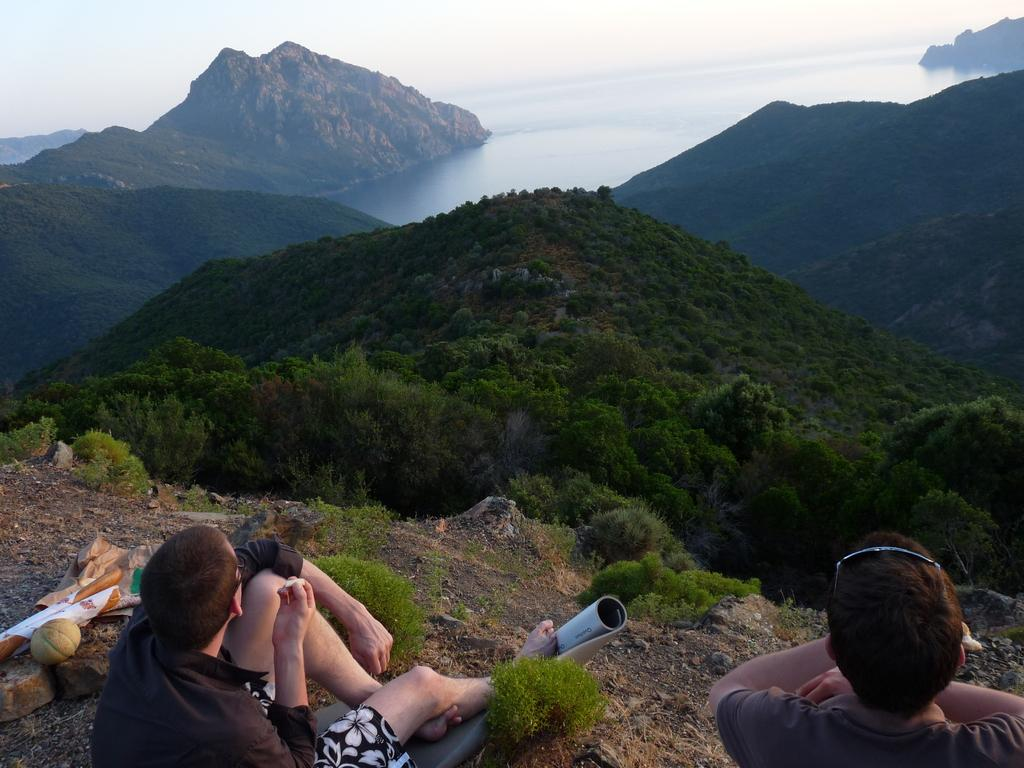Who or what can be seen in the image? There are people in the image. What type of natural environment is visible in the image? There are trees and hills in the image. What type of tools does the spy use to bite into the carpenter's work in the image? There is no spy, bite, or carpenter present in the image. 